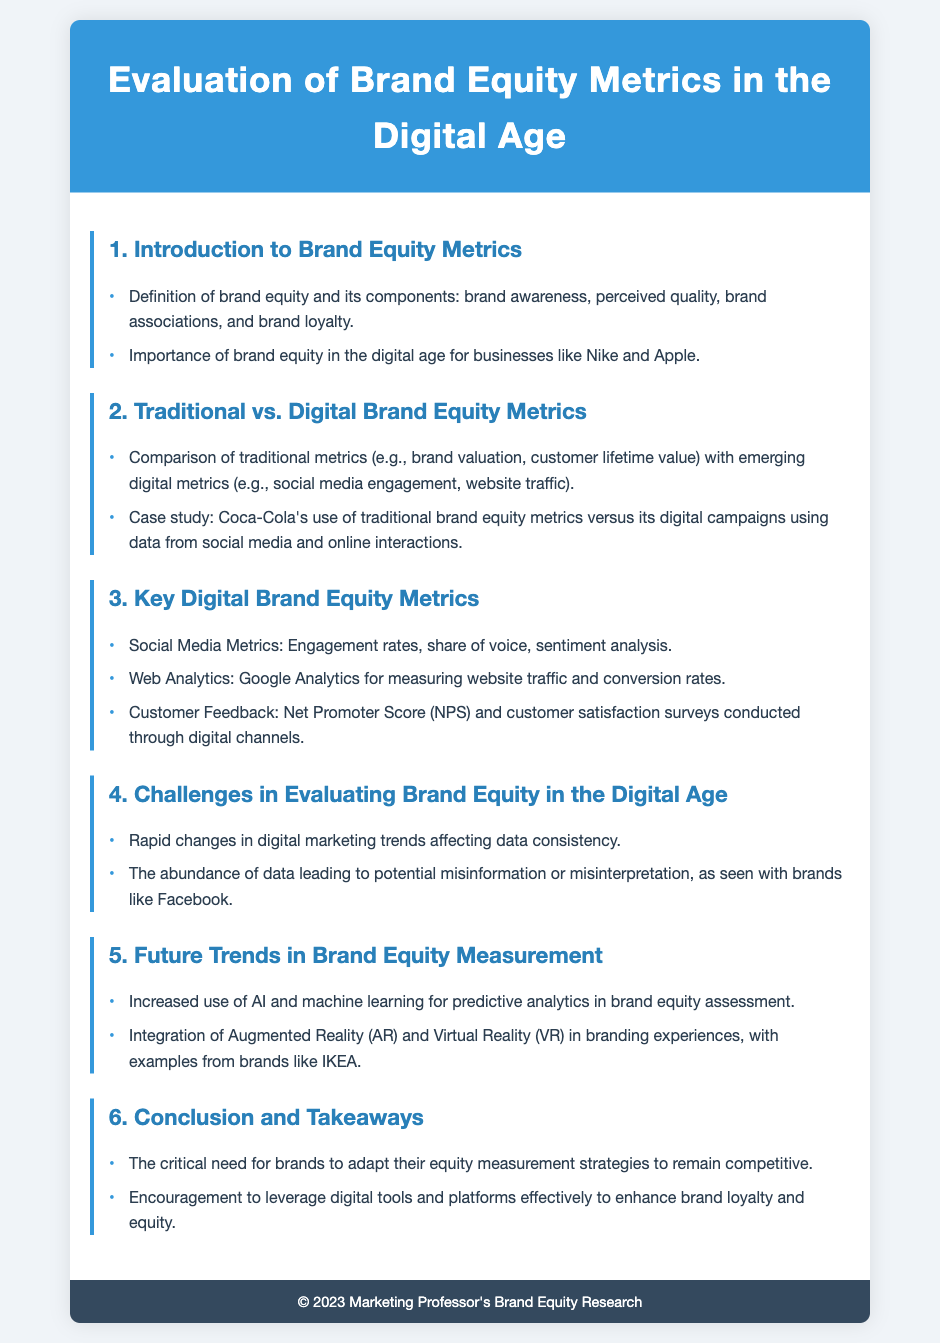What are the components of brand equity? The document lists brand awareness, perceived quality, brand associations, and brand loyalty as components of brand equity.
Answer: Brand awareness, perceived quality, brand associations, brand loyalty Which companies are highlighted for their importance of brand equity in the digital age? The document mentions Nike and Apple as examples of businesses that value brand equity in the digital age.
Answer: Nike and Apple What traditional metric compares to emerging digital metrics? The document indicates that brand valuation and customer lifetime value are traditional metrics compared with social media engagement and website traffic.
Answer: Brand valuation, customer lifetime value What is one key digital brand equity metric mentioned? The document states that social media metrics, web analytics, and customer feedback are key digital brand equity metrics; one example given is engagement rates.
Answer: Engagement rates What challenges in evaluating brand equity in the digital age are discussed? The document highlights rapid changes in digital marketing trends and the abundance of data leading to misinformation as challenges.
Answer: Rapid changes, abundance of data What technology is mentioned for future trends in brand equity measurement? The document specifies the increased use of AI and machine learning for predictive analytics as a future trend.
Answer: AI and machine learning Which brands are used as examples in the future trends section? The document references IKEA as an example for the integration of AR and VR in branding experiences.
Answer: IKEA 